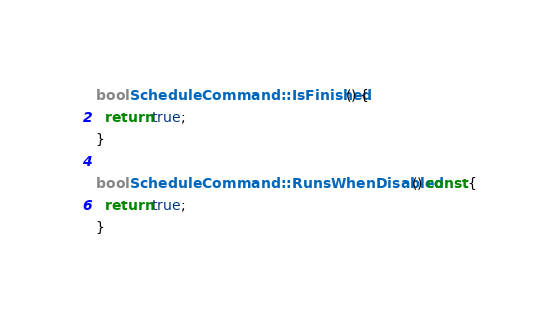Convert code to text. <code><loc_0><loc_0><loc_500><loc_500><_C++_>
bool ScheduleCommand::IsFinished() {
  return true;
}

bool ScheduleCommand::RunsWhenDisabled() const {
  return true;
}
</code> 